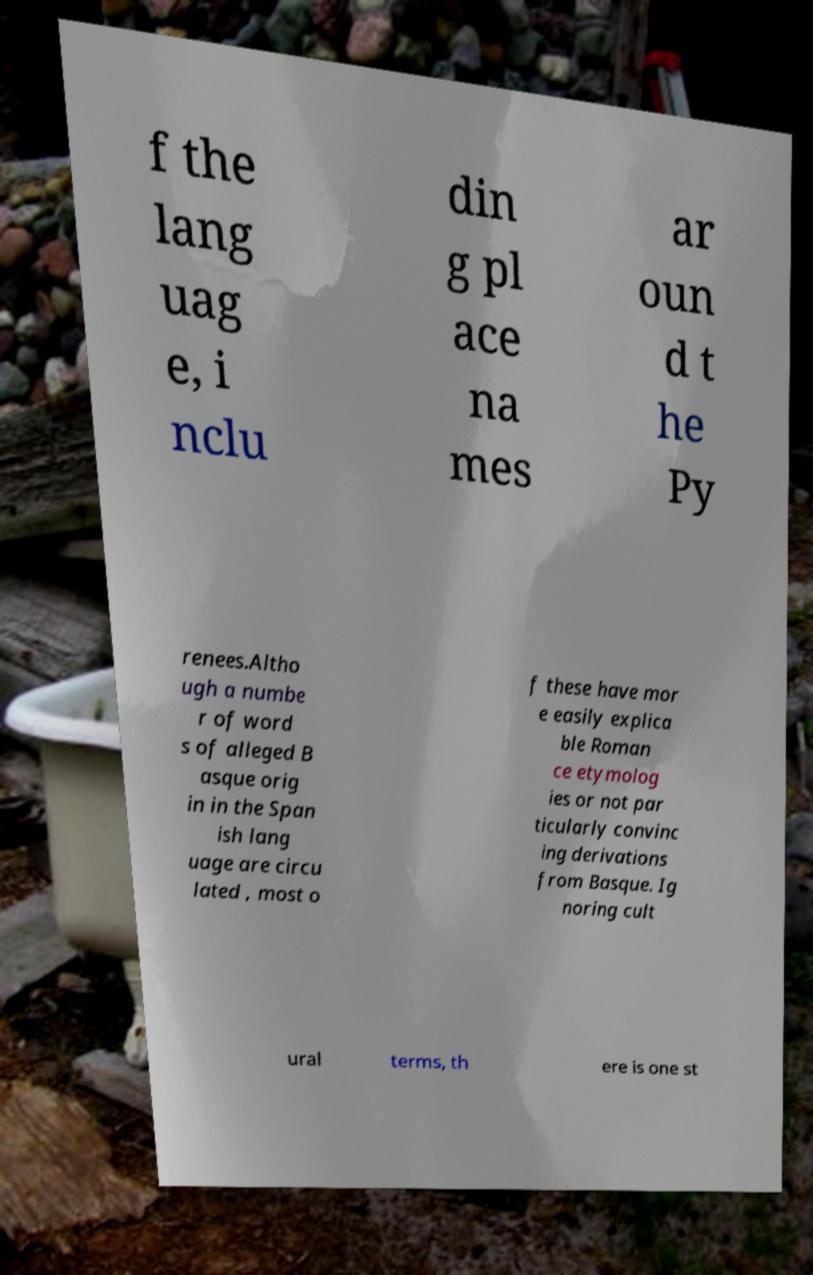Can you read and provide the text displayed in the image?This photo seems to have some interesting text. Can you extract and type it out for me? f the lang uag e, i nclu din g pl ace na mes ar oun d t he Py renees.Altho ugh a numbe r of word s of alleged B asque orig in in the Span ish lang uage are circu lated , most o f these have mor e easily explica ble Roman ce etymolog ies or not par ticularly convinc ing derivations from Basque. Ig noring cult ural terms, th ere is one st 